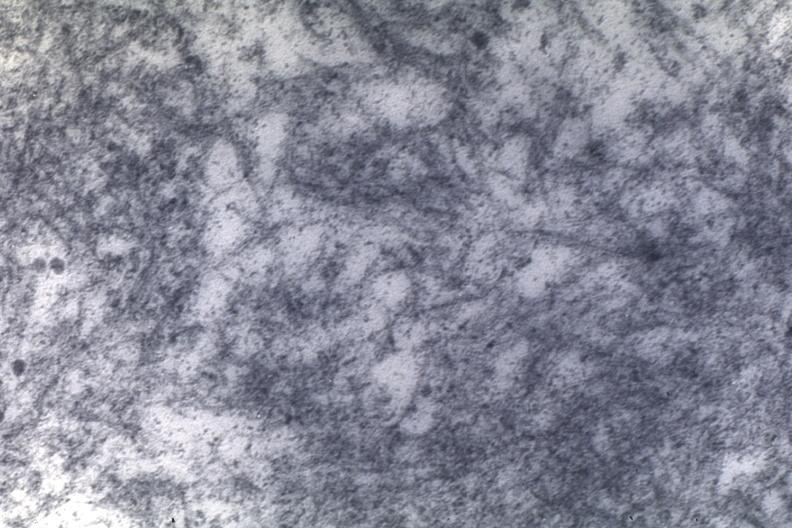what is present?
Answer the question using a single word or phrase. Cardiovascular 